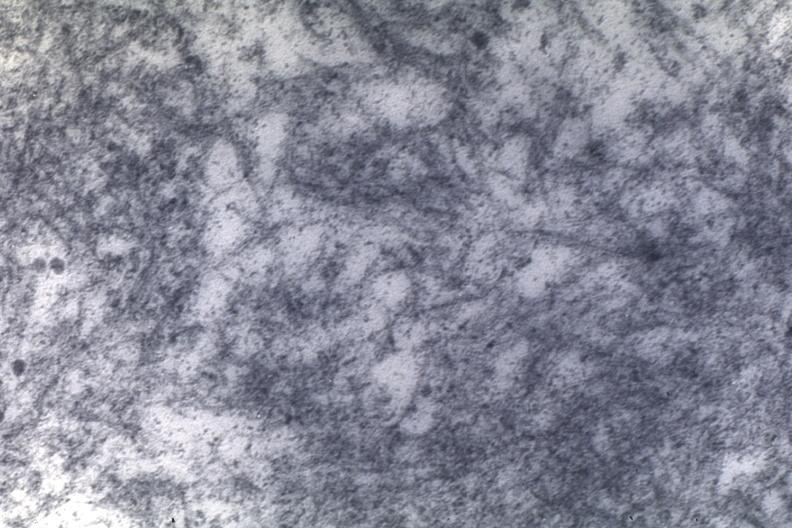what is present?
Answer the question using a single word or phrase. Cardiovascular 